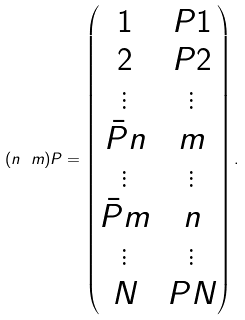Convert formula to latex. <formula><loc_0><loc_0><loc_500><loc_500>( n \ m ) P = \begin{pmatrix} 1 & P 1 \\ 2 & P 2 \\ \vdots & \vdots \\ \bar { P } n & m \\ \vdots & \vdots \\ \bar { P } m & n \\ \vdots & \vdots \\ N & P N \end{pmatrix} .</formula> 